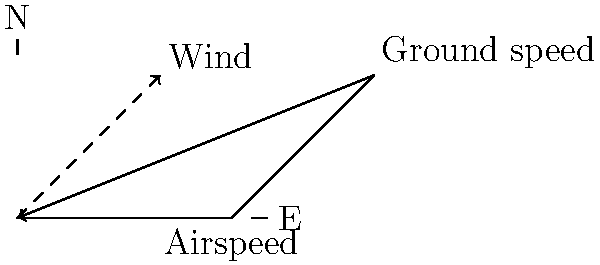An aircraft is flying with a true airspeed of 150 knots on a heading of 090°. The wind is blowing from 320° at 30 knots. Calculate the aircraft's ground speed and true course (track). To solve this problem, we'll use vector addition and trigonometry. Let's break it down step-by-step:

1. Convert the given information to vector components:

   Airspeed vector:
   - Magnitude: 150 knots
   - Direction: 090° (due East)
   - Components: $$(150 \cos 0°, 150 \sin 0°) = (150, 0)$$

   Wind vector (note: we use the reciprocal of 320° as the wind is blowing from this direction):
   - Magnitude: 30 knots
   - Direction: 140° (320° - 180°)
   - Components: $$(30 \cos 140°, 30 \sin 140°) = (-22.98, 19.28)$$

2. Add the vectors to find the ground speed vector:
   $$(150, 0) + (-22.98, 19.28) = (127.02, 19.28)$$

3. Calculate the ground speed (magnitude of the resulting vector):
   $$\text{Ground Speed} = \sqrt{127.02^2 + 19.28^2} = 128.47 \text{ knots}$$

4. Calculate the true course (track) using arctangent:
   $$\text{True Course} = \arctan\left(\frac{19.28}{127.02}\right) = 8.63°$$

Therefore, the aircraft's ground speed is approximately 128.5 knots, and its true course (track) is about 009° (rounded to the nearest degree).
Answer: Ground speed: 128.5 knots, True course: 009° 